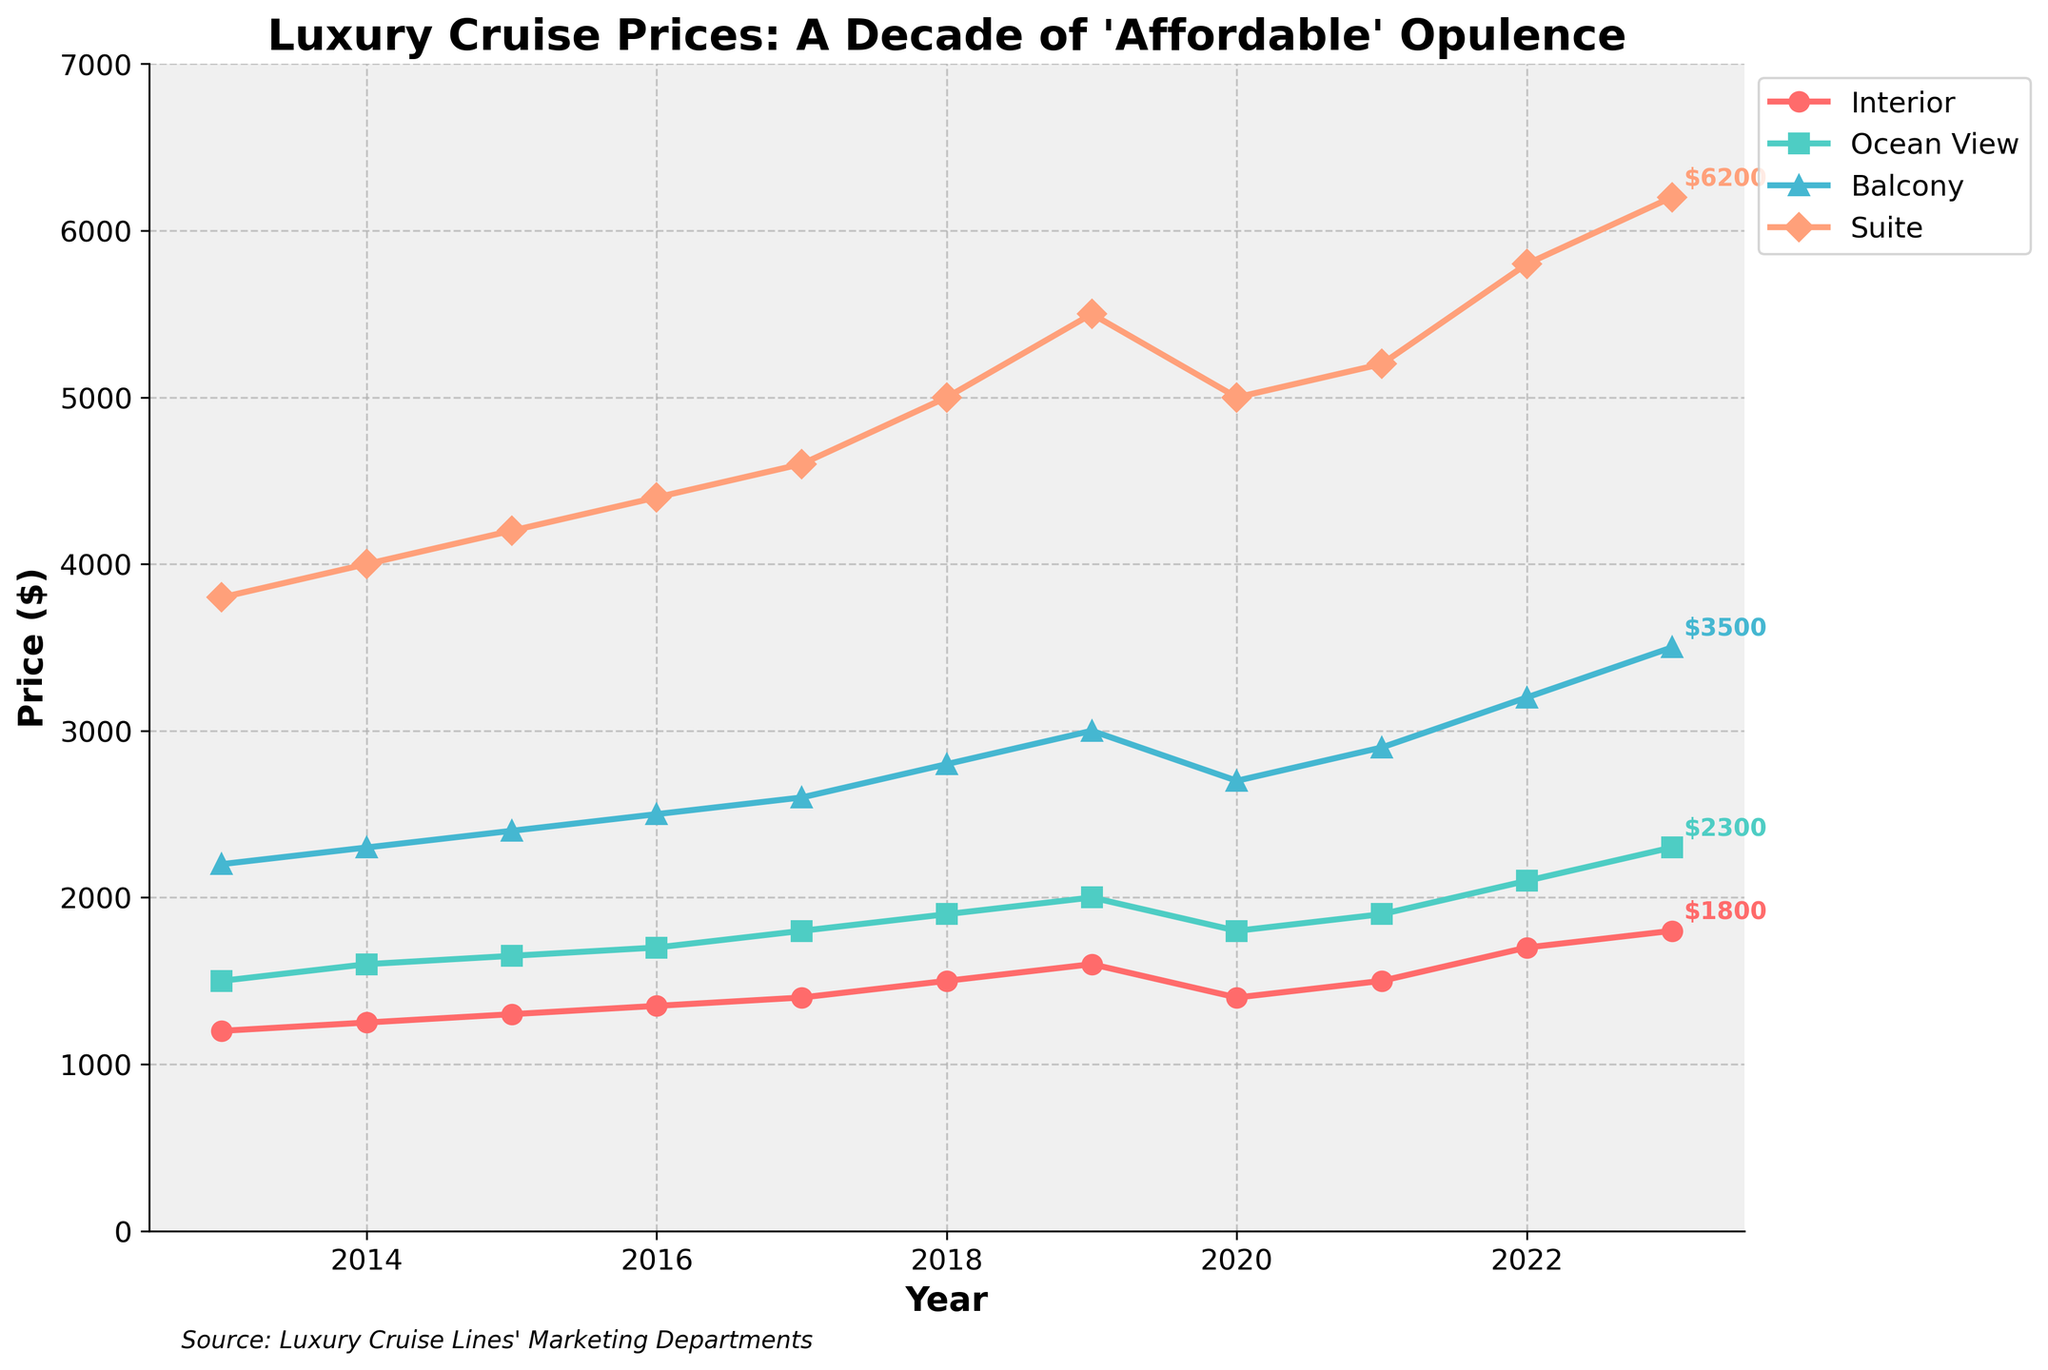What was the average price of a Balcony cabin from 2013 to 2016? To find the average price of a Balcony cabin from 2013 to 2016, sum up the prices for those years and divide by the number of years: (2200 + 2300 + 2400 + 2500) / 4 = 2350.
Answer: 2350 Which cabin class shows the highest increase in price from 2013 to 2023? Compare the price increase for each cabin class from 2013 to 2023: Interior: 1800 - 1200 = 600, Ocean View: 2300 - 1500 = 800, Balcony: 3500 - 2200 = 1300, Suite: 6200 - 3800 = 2400. The Suite class shows the highest increase.
Answer: Suite How does the price of an Ocean View cabin in 2019 compare to the Suite price in 2020? Look at the prices on the graph for Ocean View in 2019 and Suite in 2020: Ocean View in 2019 is 2000, Suite in 2020 is 5000. The Suite price in 2020 is significantly higher.
Answer: The Suite price in 2020 is higher What year did the Interior cabin price first exceed $1600? Identify the year when the Interior cabin price first goes over $1600 by following the trend line: The price exceeds $1600 in 2022.
Answer: 2022 What is the total sum of the prices for Suite cabins from 2017 to 2023? Add the prices of Suite cabins from 2017 to 2023: 4600 + 5000 + 5500 + 5000 + 5200 + 5800 + 6200 = 37300.
Answer: 37300 Which class had the least price volatility over the decade? Compare the stability of the price lines for each cabin class. The Interior cabin shows the least fluctuation in its trend line, especially compared to the Suite class.
Answer: Interior What is the difference in the Balcony cabin prices between 2019 and 2023? Subtract the Balcony cabin price in 2019 from the price in 2023: 3500 - 3000 = 500.
Answer: 500 In what year did the Ocean View cabin price experience its first decrease, and by how much? Identify the first year where the Ocean View cabin price dropped, and calculate the decrease: Ocean View price drops from 2000 in 2019 to 1800 in 2020, a decrease of 200.
Answer: 2020, 200 